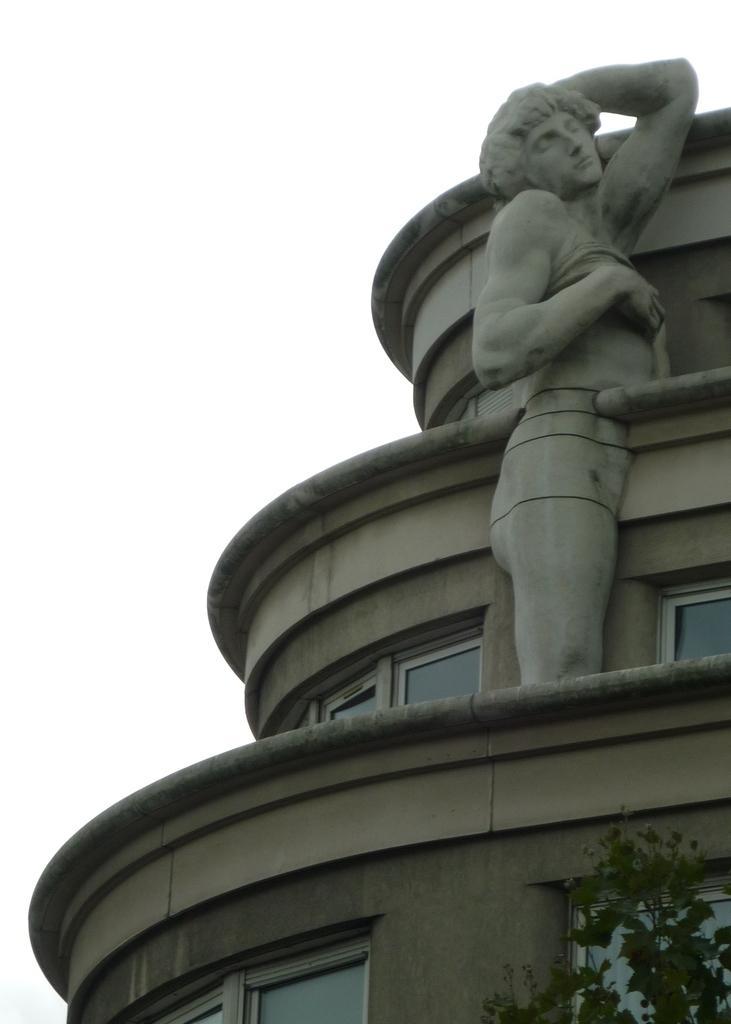Please provide a concise description of this image. In this image, we can see a human structure on the building and there is a tree on the bottom right. 